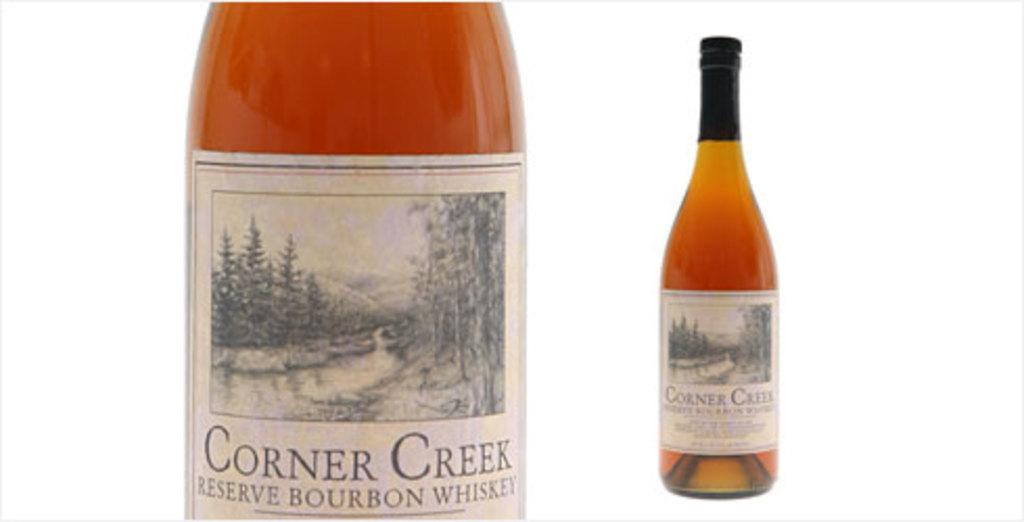<image>
Summarize the visual content of the image. the word corner creek that is on a bottle 